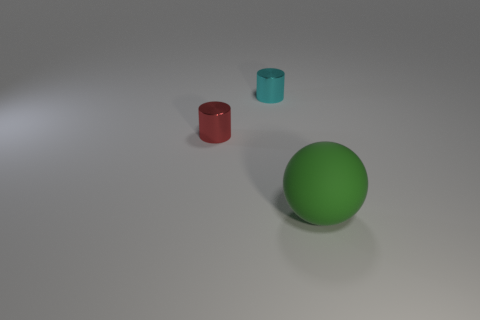What is the color of the large matte thing? green 